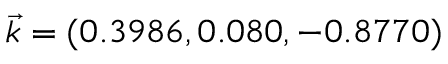<formula> <loc_0><loc_0><loc_500><loc_500>\vec { k } = ( 0 . 3 9 8 6 , 0 . 0 8 0 , - 0 . 8 7 7 0 )</formula> 